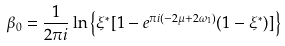<formula> <loc_0><loc_0><loc_500><loc_500>\beta _ { 0 } = \frac { 1 } { 2 \pi i } \ln \left \{ \xi ^ { * } [ 1 - e ^ { \pi i ( - 2 \mu + 2 \omega _ { 1 } ) } ( 1 - \xi ^ { * } ) ] \right \}</formula> 